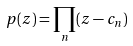Convert formula to latex. <formula><loc_0><loc_0><loc_500><loc_500>p ( z ) = \prod _ { n } ( z - c _ { n } )</formula> 